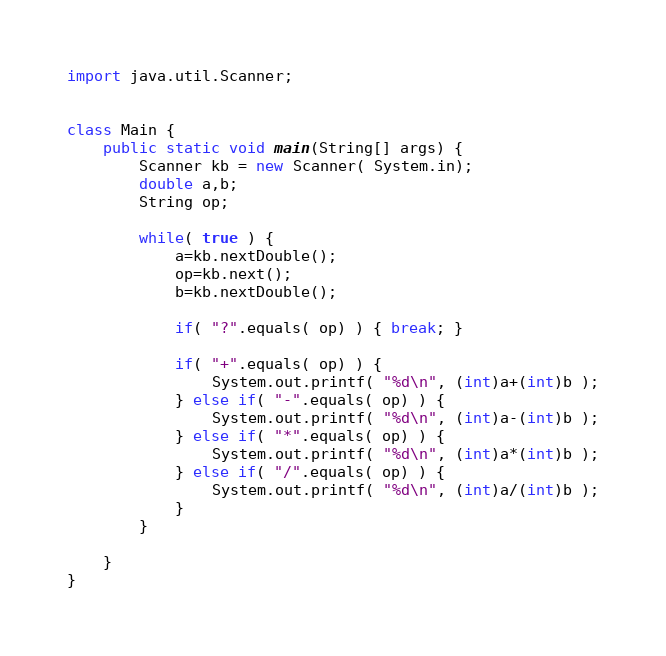Convert code to text. <code><loc_0><loc_0><loc_500><loc_500><_Java_>import java.util.Scanner;


class Main {
	public static void main(String[] args) {
		Scanner kb = new Scanner( System.in);	
		double a,b;
		String op;
		
		while( true ) {
			a=kb.nextDouble();
			op=kb.next();
			b=kb.nextDouble();
			
			if( "?".equals( op) ) { break; }
			
			if( "+".equals( op) ) {
				System.out.printf( "%d\n", (int)a+(int)b );
			} else if( "-".equals( op) ) {
				System.out.printf( "%d\n", (int)a-(int)b );
			} else if( "*".equals( op) ) {
				System.out.printf( "%d\n", (int)a*(int)b );
			} else if( "/".equals( op) ) {
				System.out.printf( "%d\n", (int)a/(int)b );
			}
		}
			
	}
}</code> 